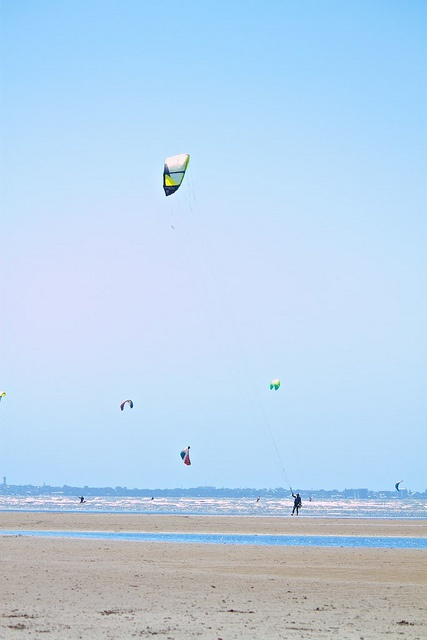Describe the objects in this image and their specific colors. I can see kite in lightblue, white, navy, and darkgray tones, kite in lightblue, darkgray, lavender, and gray tones, people in lightblue, black, navy, and gray tones, kite in lightblue, white, teal, green, and turquoise tones, and kite in lightblue, darkgray, blue, and purple tones in this image. 